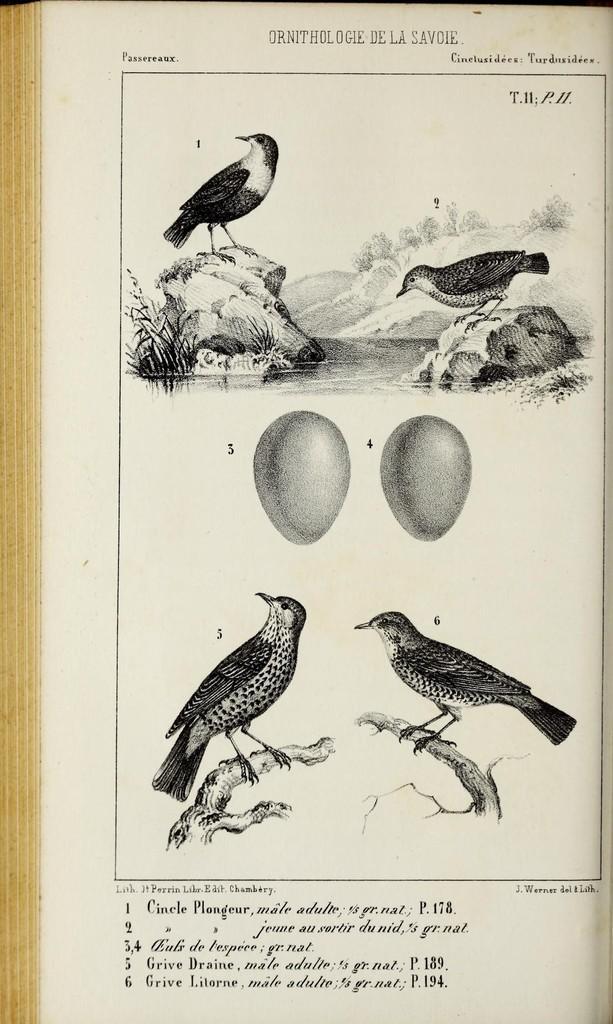Describe this image in one or two sentences. In this image we can see a picture of a book inn which there are few birds standing on an object and two eggs. There is some text written on it and we can see some plants, mountain and water. 